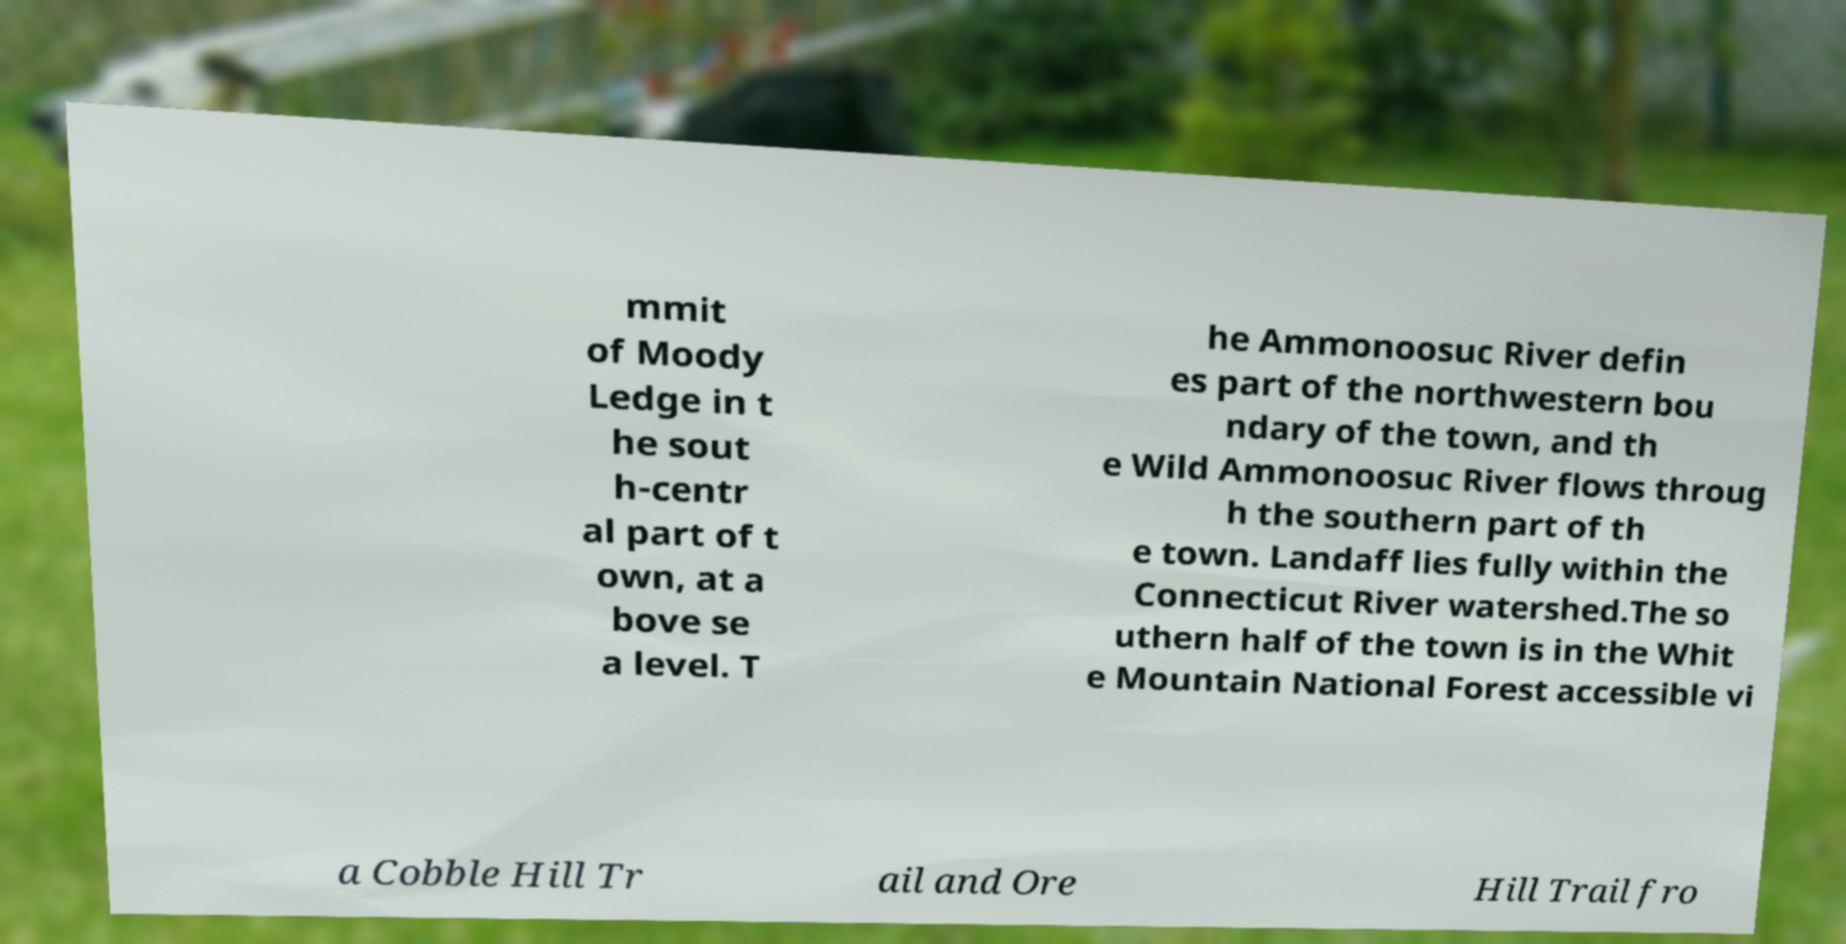There's text embedded in this image that I need extracted. Can you transcribe it verbatim? mmit of Moody Ledge in t he sout h-centr al part of t own, at a bove se a level. T he Ammonoosuc River defin es part of the northwestern bou ndary of the town, and th e Wild Ammonoosuc River flows throug h the southern part of th e town. Landaff lies fully within the Connecticut River watershed.The so uthern half of the town is in the Whit e Mountain National Forest accessible vi a Cobble Hill Tr ail and Ore Hill Trail fro 